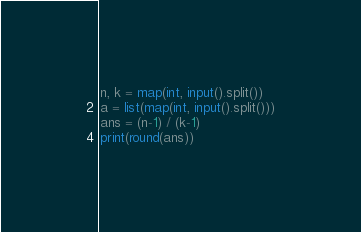<code> <loc_0><loc_0><loc_500><loc_500><_Python_>n, k = map(int, input().split())
a = list(map(int, input().split()))
ans = (n-1) / (k-1)
print(round(ans))</code> 